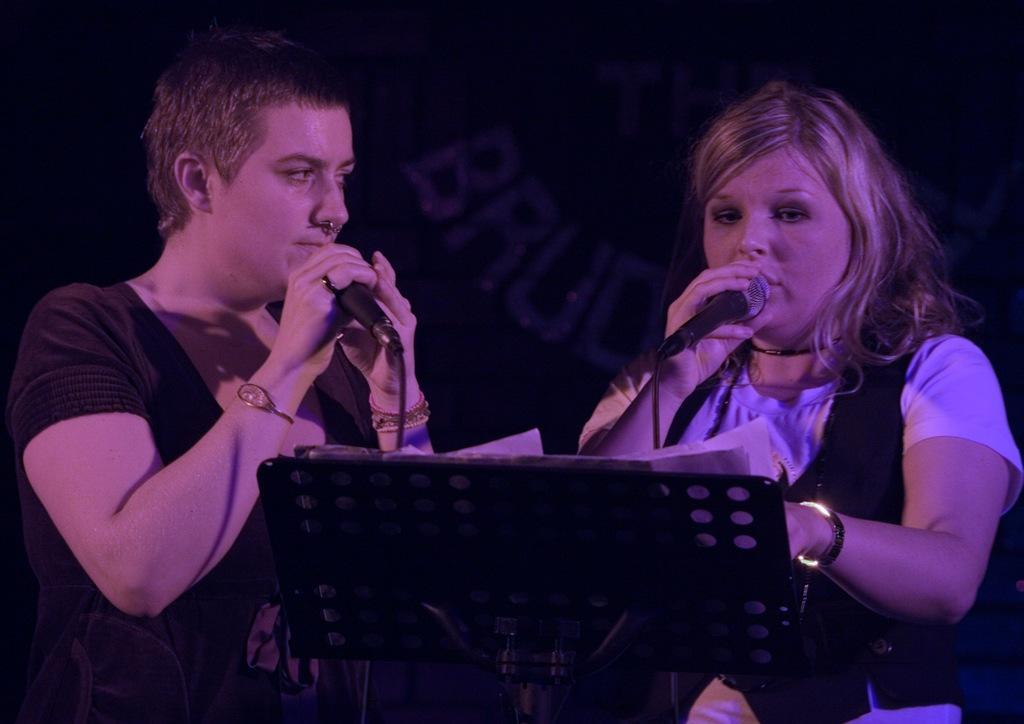Please provide a concise description of this image. In this image, we can see people and are holding mics and we can see a podium and some papers on it. In the background, there is some text. 